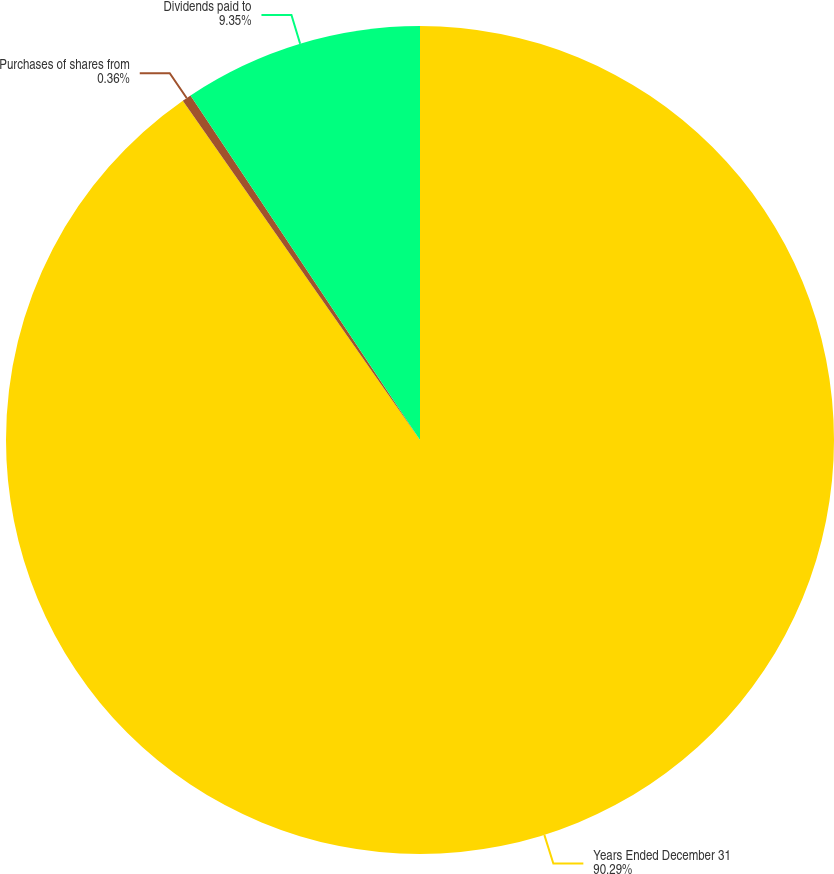<chart> <loc_0><loc_0><loc_500><loc_500><pie_chart><fcel>Years Ended December 31<fcel>Purchases of shares from<fcel>Dividends paid to<nl><fcel>90.29%<fcel>0.36%<fcel>9.35%<nl></chart> 